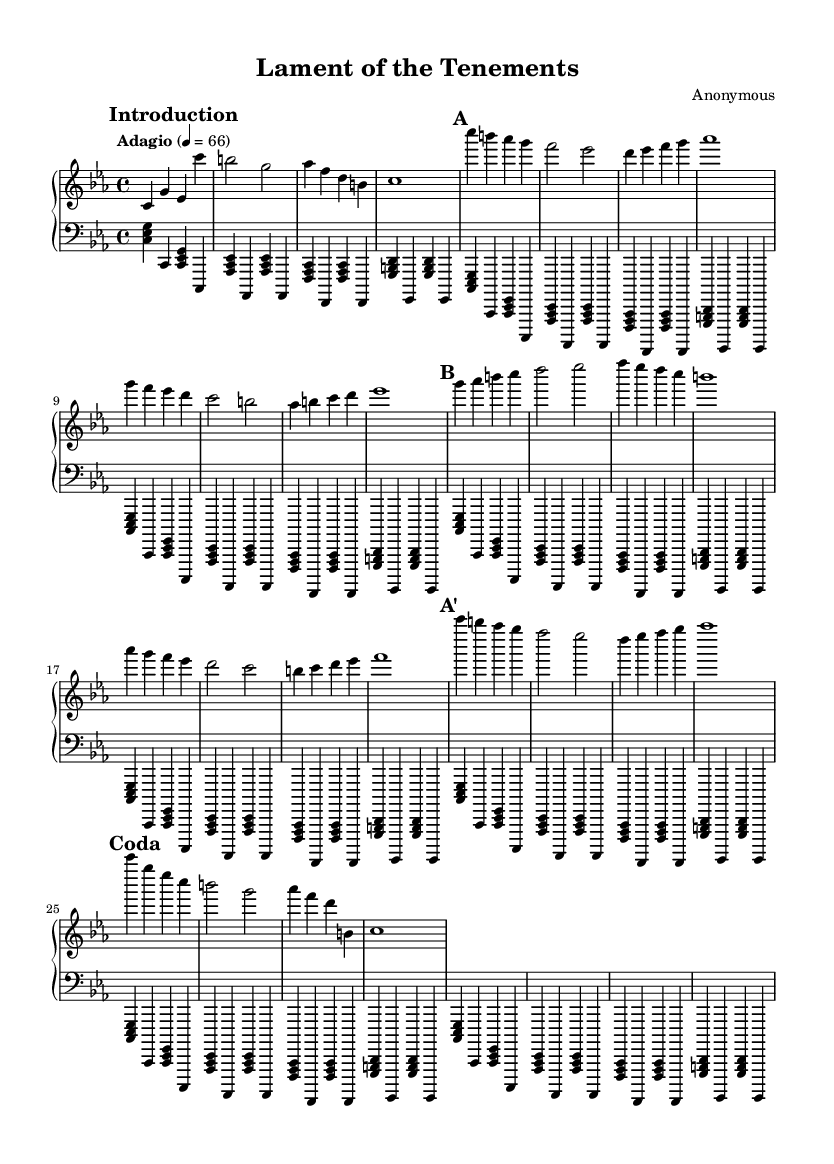What is the key signature of this music? The key signature is C minor, identifiable by its three flat notes: B-flat, E-flat, and A-flat. This is confirmed by checking the key signature displayed at the beginning of the staff.
Answer: C minor What is the time signature of this music? The time signature is 4/4, which can be found next to the key signature at the beginning of the score. This means there are four beats in each measure, with each beat represented by a quarter note.
Answer: 4/4 What is the tempo marking for this piece? The tempo marking is "Adagio," which is written above the staff. Adagio indicates a slow pace, typically around 66 beats per minute as indicated next to it.
Answer: Adagio How many sections does the piece have? The piece has four distinct sections labeled as Introduction, A, B, and A' (abbreviated), followed by a Coda. These sections are indicated in the score with marked titles that differentiate them.
Answer: Four What is the final chord of the piece? The final chord is a C major chord, displayed in the Coda section. It consists of the notes C, E, and G played together in the last measure, visually confirming its major quality.
Answer: C major Does the left hand play a repeating pattern? Yes, the left hand uses a repeating pattern of broken chords and octave bass notes. This is evident in the consistent style of the left-hand part throughout the score.
Answer: Yes What is the dynamic marking at the beginning of the piece? The dynamic marking is not explicitly stated in the given excerpt, but typically for pieces like this, it might be expected to start with a soft dynamic, such as piano. As it is missing, we cannot confirm a specific marking.
Answer: Not specified 